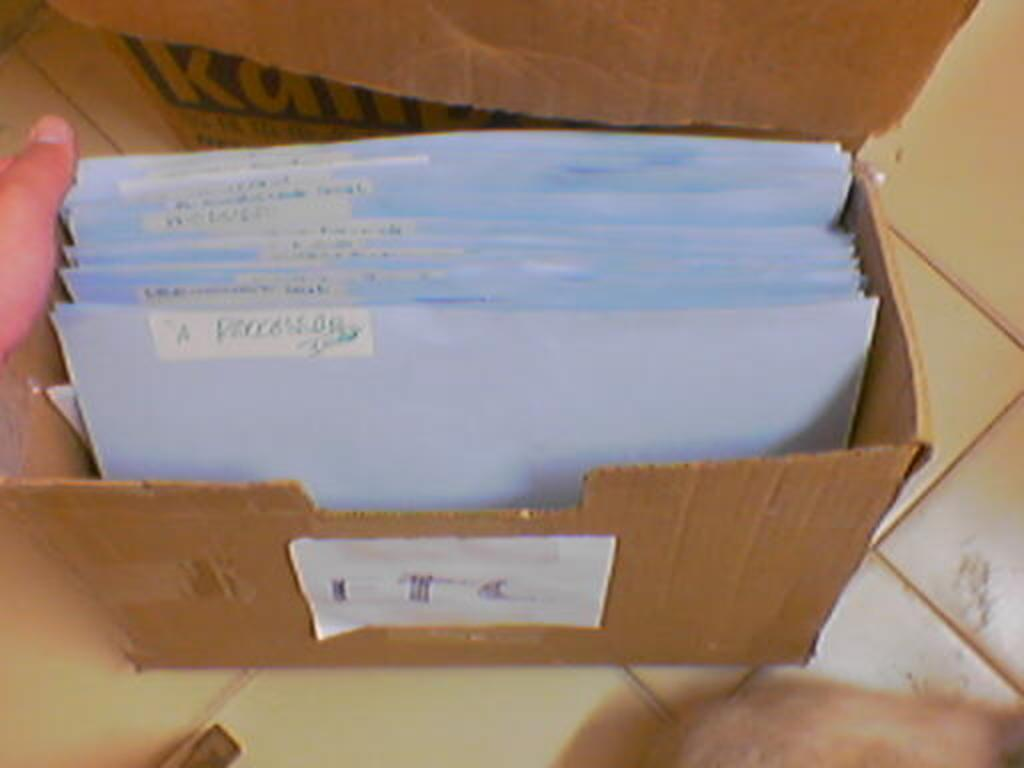What object is present in the image that is typically used for storage or transportation? There is a cardboard box in the image. What is inside the cardboard box? The cardboard box contains papers. Can you describe the describe the position of the person's hand in the image? A person's hand is visible on the left side of the image. Where is the cardboard box located in the image? The cardboard box is placed on the floor. What type of engine can be seen powering the cup in the image? There is no engine or cup present in the image; it features a cardboard box with papers and a person's hand. How does the person's hand improve their hearing in the image? The person's hand does not improve their hearing in the image; it is simply visible on the left side of the image. 